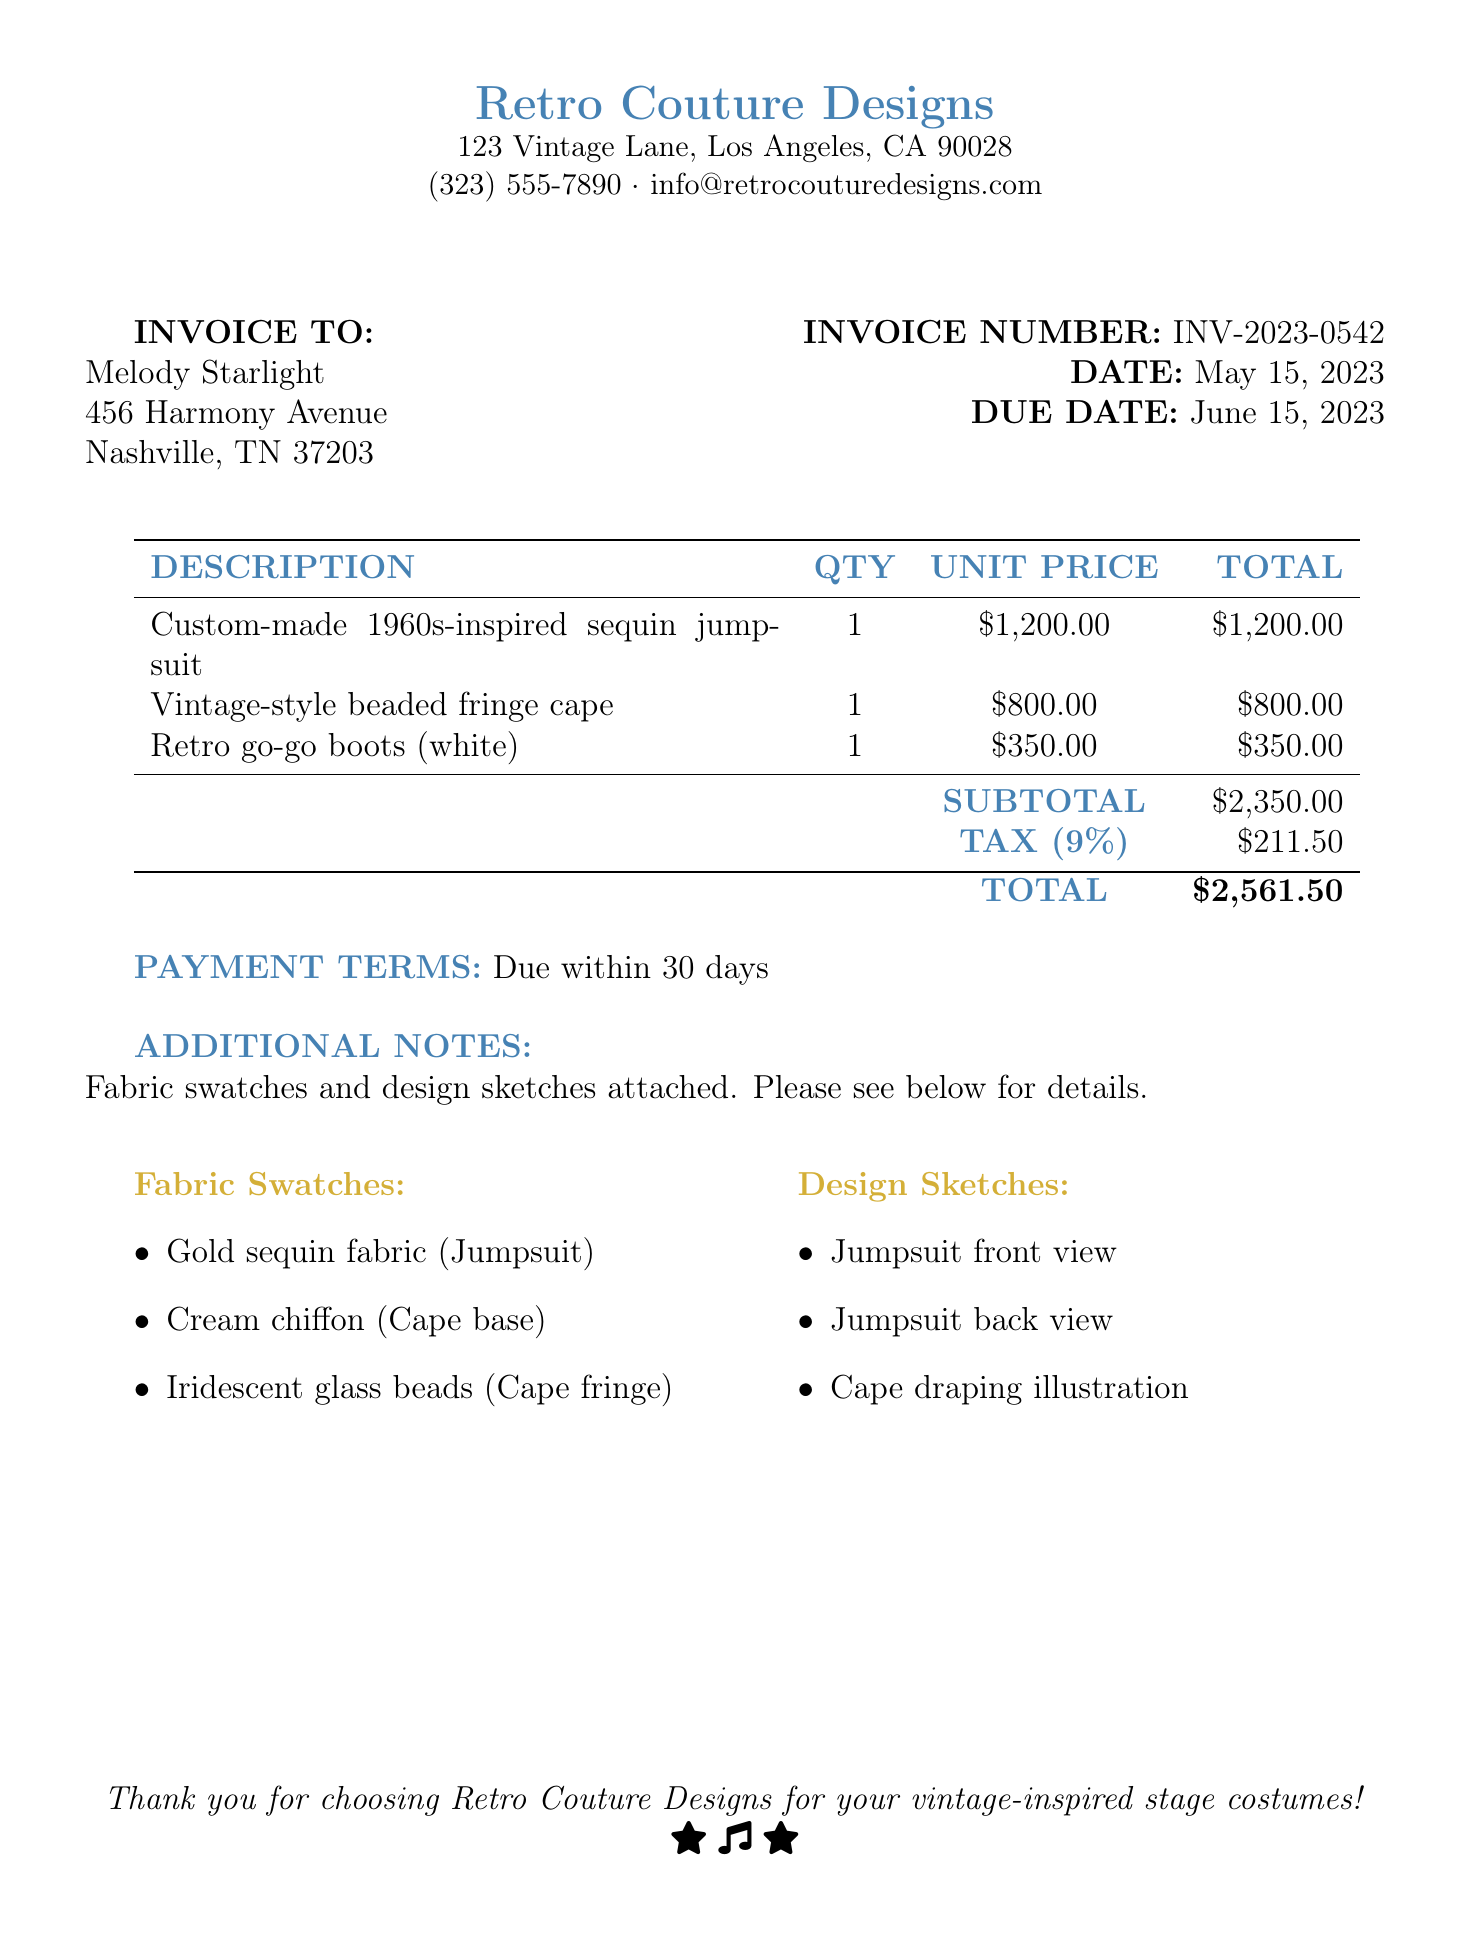What is the invoice number? The invoice number is specified in the document to identify this particular invoice.
Answer: INV-2023-0542 What is the due date for the invoice? The due date indicates when the payment is expected.
Answer: June 15, 2023 What is the subtotal amount? The subtotal is the total before tax and is listed in the table of costs.
Answer: $2,350.00 How many fabric swatches are listed? The number of fabric swatches is shown under the additional notes in the document.
Answer: 3 What is the total amount due? The total amount is the final figure, including tax, calculated in the document.
Answer: $2,561.50 What is the payment terms duration? Payment terms refer to the timeframe allowed for payment as specified in the document.
Answer: 30 days What is the fabric type for the jumpsuit? The specific fabric for the jumpsuit is mentioned in the fabric swatches section.
Answer: Gold sequin fabric What design sketch is included for the cape? This question requires identifying a specific item related to the design sketches provided.
Answer: Cape draping illustration What type of boots are included in the invoice? The type of boots is specified in the description of the items invoiced.
Answer: Retro go-go boots (white) 